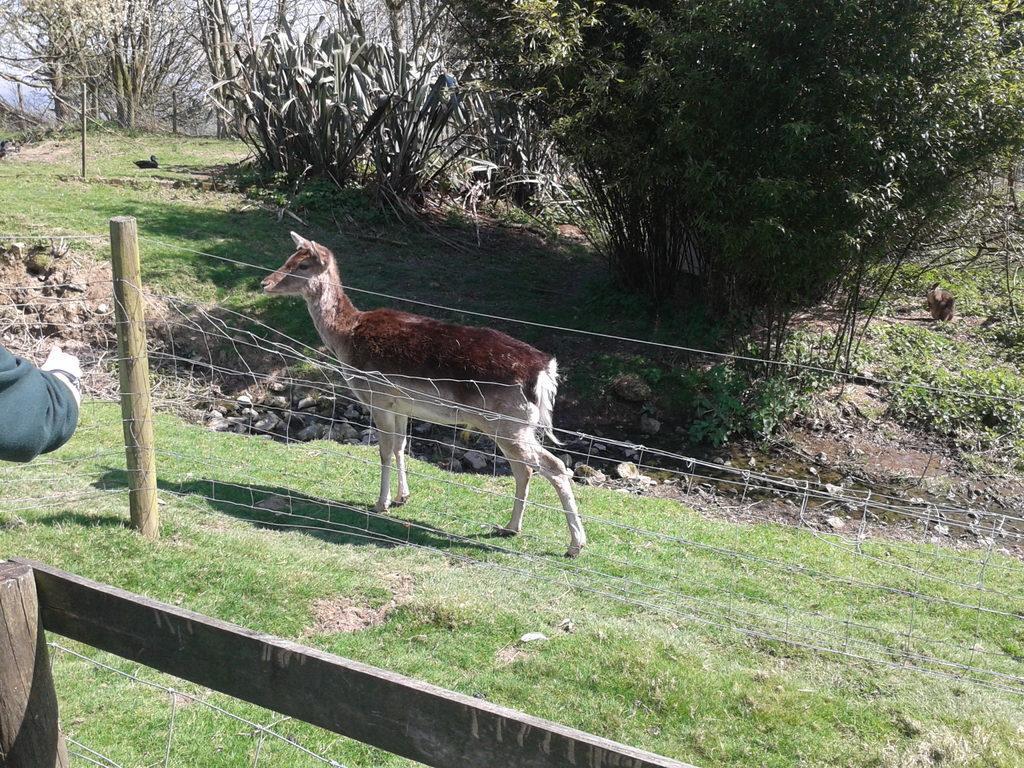Please provide a concise description of this image. In this image we can see an animal in the grass and there is a fence. We can also see some plants and trees and there is a duck. 